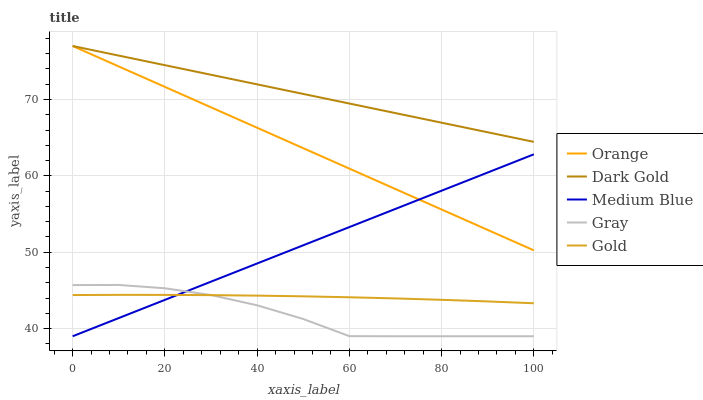Does Medium Blue have the minimum area under the curve?
Answer yes or no. No. Does Medium Blue have the maximum area under the curve?
Answer yes or no. No. Is Gray the smoothest?
Answer yes or no. No. Is Medium Blue the roughest?
Answer yes or no. No. Does Gold have the lowest value?
Answer yes or no. No. Does Gray have the highest value?
Answer yes or no. No. Is Medium Blue less than Dark Gold?
Answer yes or no. Yes. Is Dark Gold greater than Gray?
Answer yes or no. Yes. Does Medium Blue intersect Dark Gold?
Answer yes or no. No. 